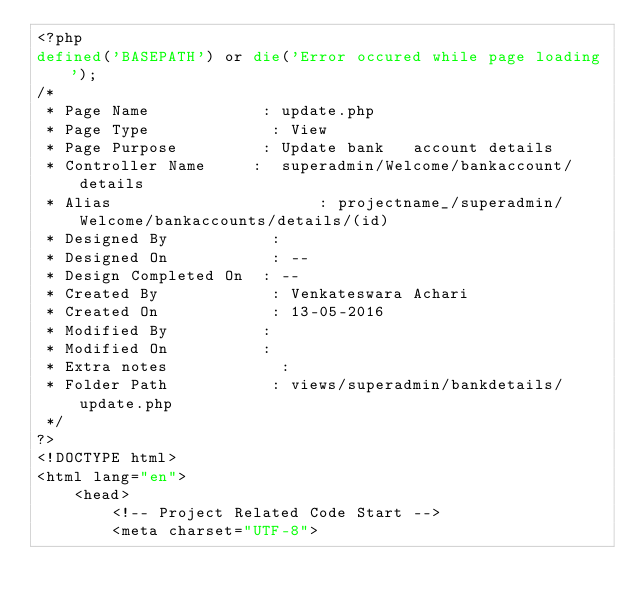<code> <loc_0><loc_0><loc_500><loc_500><_PHP_><?php
defined('BASEPATH') or die('Error occured while page loading');
/*
 * Page Name            : update.php
 * Page Type             : View
 * Page Purpose         : Update bank   account details
 * Controller Name     :  superadmin/Welcome/bankaccount/details
 * Alias                      : projectname_/superadmin/Welcome/bankaccounts/details/(id)
 * Designed By           : 
 * Designed On           : --
 * Design Completed On  : --
 * Created By            : Venkateswara Achari
 * Created On            : 13-05-2016
 * Modified By          : 
 * Modified On          : 
 * Extra notes            :
 * Folder Path           : views/superadmin/bankdetails/update.php
 */
?>
<!DOCTYPE html>
<html lang="en">
    <head>
        <!-- Project Related Code Start -->
        <meta charset="UTF-8"></code> 